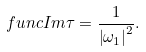Convert formula to latex. <formula><loc_0><loc_0><loc_500><loc_500>\ f u n c { I m } \tau = \frac { 1 } { \left | \omega _ { 1 } \right | ^ { 2 } } .</formula> 